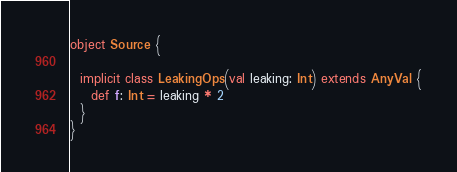<code> <loc_0><loc_0><loc_500><loc_500><_Scala_>object Source {

  implicit class LeakingOps(val leaking: Int) extends AnyVal {
    def f: Int = leaking * 2
  }
}
</code> 